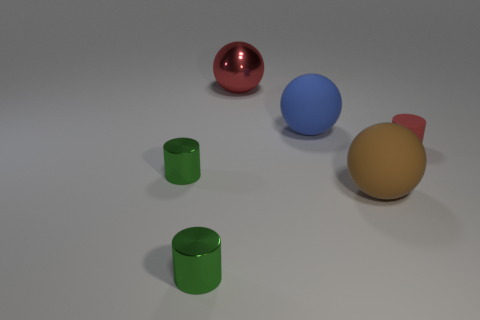Do the red thing that is in front of the big red thing and the rubber ball left of the brown object have the same size?
Your response must be concise. No. What number of other objects are the same size as the brown sphere?
Your response must be concise. 2. There is a blue thing that is in front of the large red thing; what number of large matte spheres are left of it?
Your answer should be very brief. 0. Are there fewer large red balls on the left side of the rubber cylinder than red spheres?
Provide a succinct answer. No. There is a small object right of the shiny thing right of the tiny green metal cylinder that is in front of the brown object; what shape is it?
Give a very brief answer. Cylinder. Is the big blue rubber thing the same shape as the big red metallic thing?
Offer a terse response. Yes. How many other objects are there of the same shape as the small red matte object?
Your response must be concise. 2. There is a rubber sphere that is the same size as the blue rubber thing; what color is it?
Offer a very short reply. Brown. Is the number of tiny cylinders that are in front of the red matte cylinder the same as the number of tiny shiny things?
Offer a terse response. Yes. There is a tiny object that is both behind the big brown object and left of the big brown object; what is its shape?
Your answer should be compact. Cylinder. 